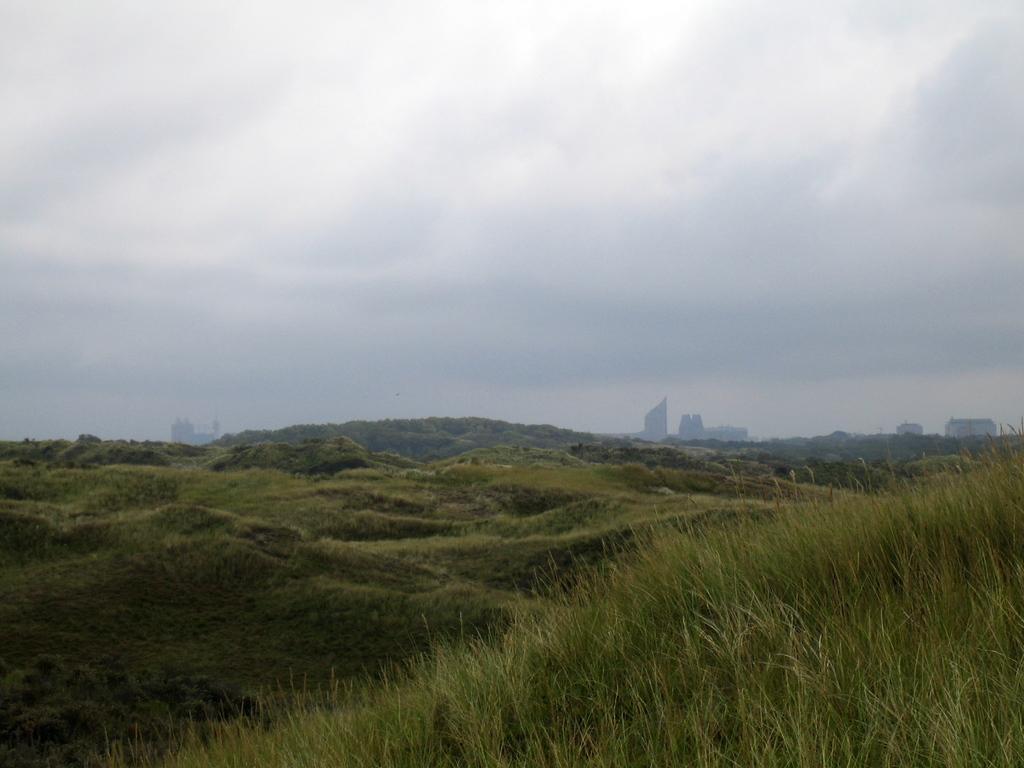Could you give a brief overview of what you see in this image? In this picture we can see the land covered with green grass and hills. The sky is cloudy. 